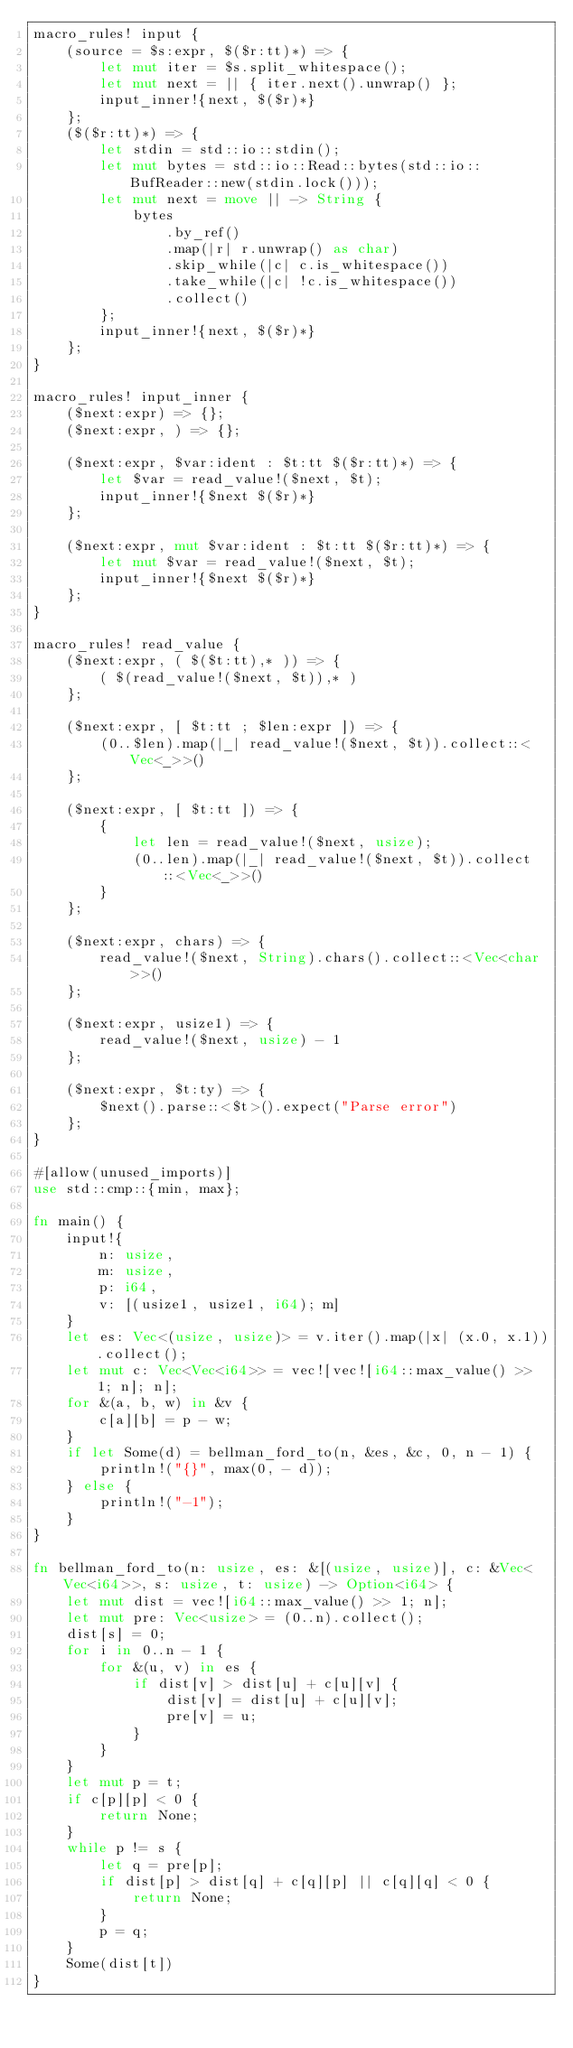<code> <loc_0><loc_0><loc_500><loc_500><_Rust_>macro_rules! input {
    (source = $s:expr, $($r:tt)*) => {
        let mut iter = $s.split_whitespace();
        let mut next = || { iter.next().unwrap() };
        input_inner!{next, $($r)*}
    };
    ($($r:tt)*) => {
        let stdin = std::io::stdin();
        let mut bytes = std::io::Read::bytes(std::io::BufReader::new(stdin.lock()));
        let mut next = move || -> String {
            bytes
                .by_ref()
                .map(|r| r.unwrap() as char)
                .skip_while(|c| c.is_whitespace())
                .take_while(|c| !c.is_whitespace())
                .collect()
        };
        input_inner!{next, $($r)*}
    };
}

macro_rules! input_inner {
    ($next:expr) => {};
    ($next:expr, ) => {};

    ($next:expr, $var:ident : $t:tt $($r:tt)*) => {
        let $var = read_value!($next, $t);
        input_inner!{$next $($r)*}
    };

    ($next:expr, mut $var:ident : $t:tt $($r:tt)*) => {
        let mut $var = read_value!($next, $t);
        input_inner!{$next $($r)*}
    };
}

macro_rules! read_value {
    ($next:expr, ( $($t:tt),* )) => {
        ( $(read_value!($next, $t)),* )
    };

    ($next:expr, [ $t:tt ; $len:expr ]) => {
        (0..$len).map(|_| read_value!($next, $t)).collect::<Vec<_>>()
    };

    ($next:expr, [ $t:tt ]) => {
        {
            let len = read_value!($next, usize);
            (0..len).map(|_| read_value!($next, $t)).collect::<Vec<_>>()
        }
    };

    ($next:expr, chars) => {
        read_value!($next, String).chars().collect::<Vec<char>>()
    };

    ($next:expr, usize1) => {
        read_value!($next, usize) - 1
    };

    ($next:expr, $t:ty) => {
        $next().parse::<$t>().expect("Parse error")
    };
}

#[allow(unused_imports)]
use std::cmp::{min, max};

fn main() {
    input!{
        n: usize,
        m: usize,
        p: i64,
        v: [(usize1, usize1, i64); m]
    }
    let es: Vec<(usize, usize)> = v.iter().map(|x| (x.0, x.1)).collect();
    let mut c: Vec<Vec<i64>> = vec![vec![i64::max_value() >> 1; n]; n];
    for &(a, b, w) in &v {
        c[a][b] = p - w;
    }
    if let Some(d) = bellman_ford_to(n, &es, &c, 0, n - 1) {
        println!("{}", max(0, - d));
    } else {
        println!("-1");
    }
}

fn bellman_ford_to(n: usize, es: &[(usize, usize)], c: &Vec<Vec<i64>>, s: usize, t: usize) -> Option<i64> {
    let mut dist = vec![i64::max_value() >> 1; n];
    let mut pre: Vec<usize> = (0..n).collect();
    dist[s] = 0;
    for i in 0..n - 1 {
        for &(u, v) in es {
            if dist[v] > dist[u] + c[u][v] {
                dist[v] = dist[u] + c[u][v];
                pre[v] = u;
            }
        }
    }
    let mut p = t;
    if c[p][p] < 0 {
        return None;
    }
    while p != s {
        let q = pre[p];
        if dist[p] > dist[q] + c[q][p] || c[q][q] < 0 {
            return None;
        }
        p = q;
    }
    Some(dist[t])
}
</code> 